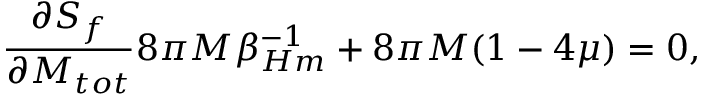<formula> <loc_0><loc_0><loc_500><loc_500>{ \frac { \partial S _ { f } } { \partial M _ { t o t } } } 8 \pi M \beta _ { H m } ^ { - 1 } + 8 \pi M ( 1 - 4 \mu ) = 0 ,</formula> 